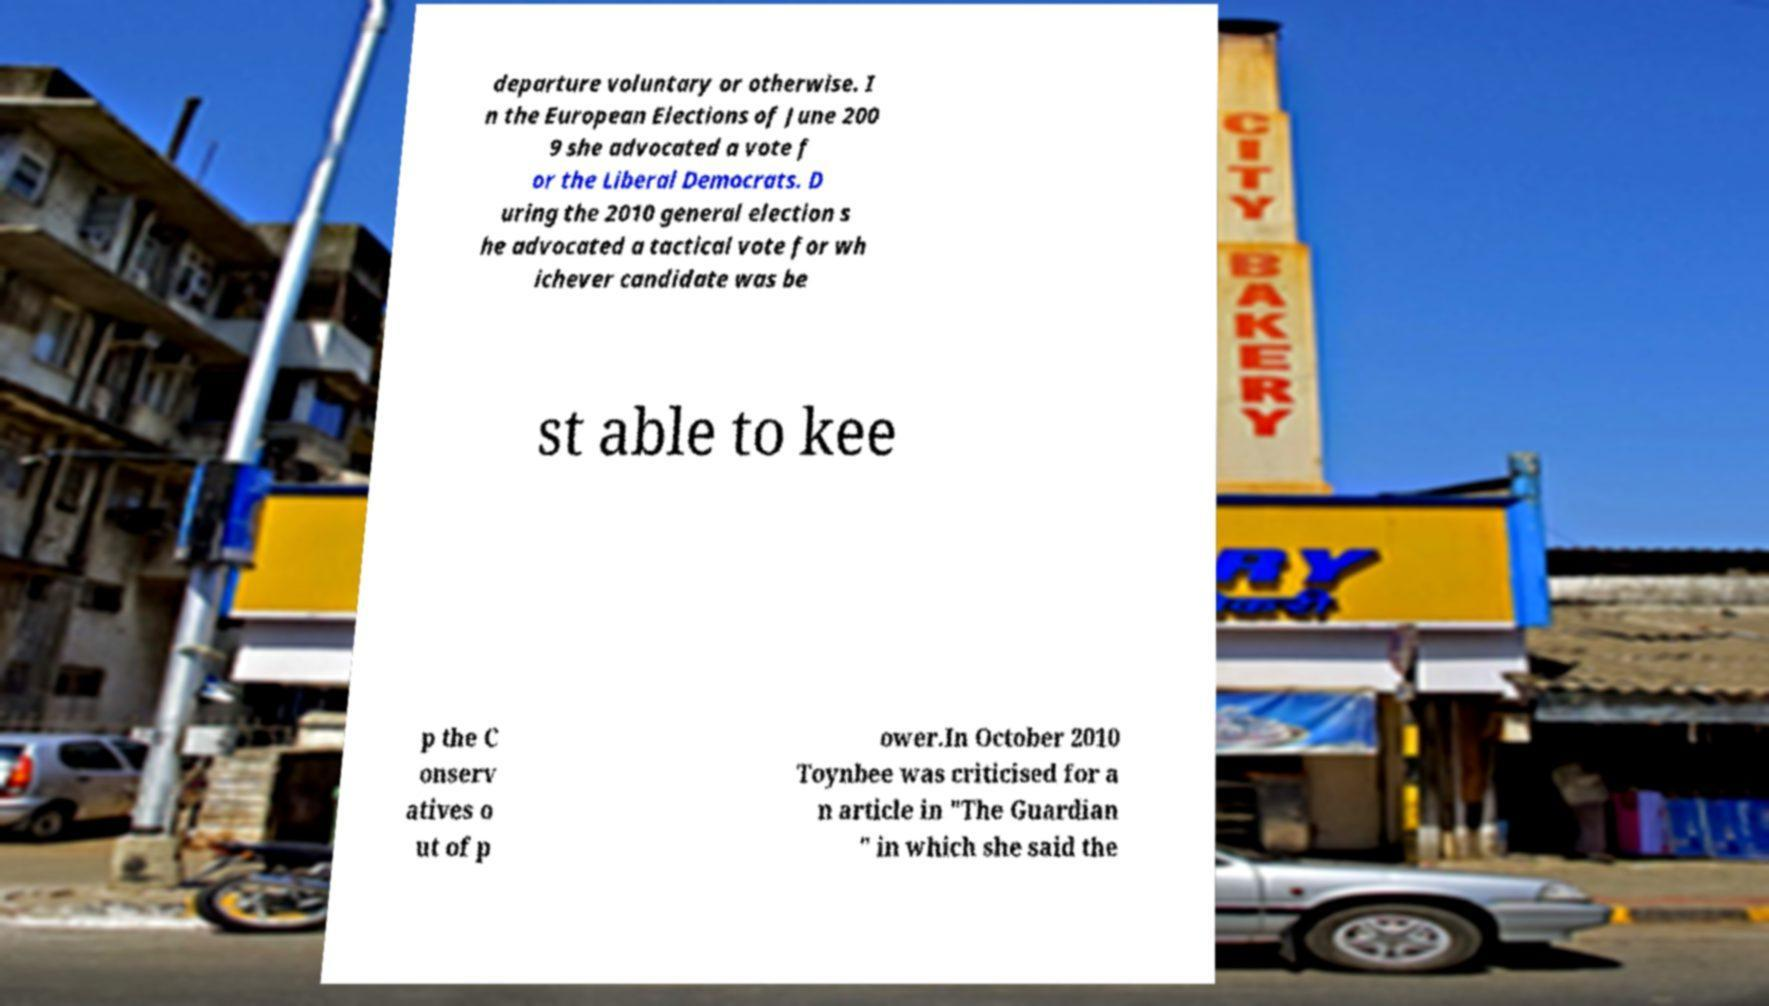Could you extract and type out the text from this image? departure voluntary or otherwise. I n the European Elections of June 200 9 she advocated a vote f or the Liberal Democrats. D uring the 2010 general election s he advocated a tactical vote for wh ichever candidate was be st able to kee p the C onserv atives o ut of p ower.In October 2010 Toynbee was criticised for a n article in "The Guardian " in which she said the 